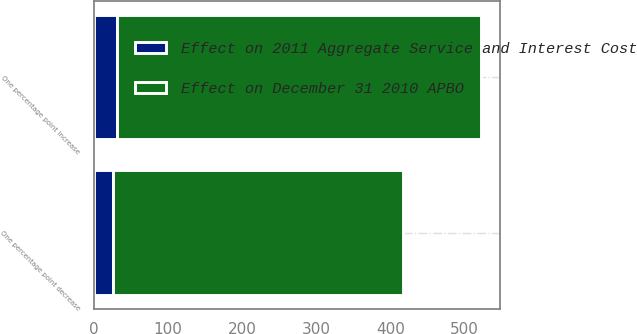Convert chart. <chart><loc_0><loc_0><loc_500><loc_500><stacked_bar_chart><ecel><fcel>One percentage point increase<fcel>One percentage point decrease<nl><fcel>Effect on 2011 Aggregate Service and Interest Cost<fcel>31<fcel>25<nl><fcel>Effect on December 31 2010 APBO<fcel>491<fcel>392<nl></chart> 